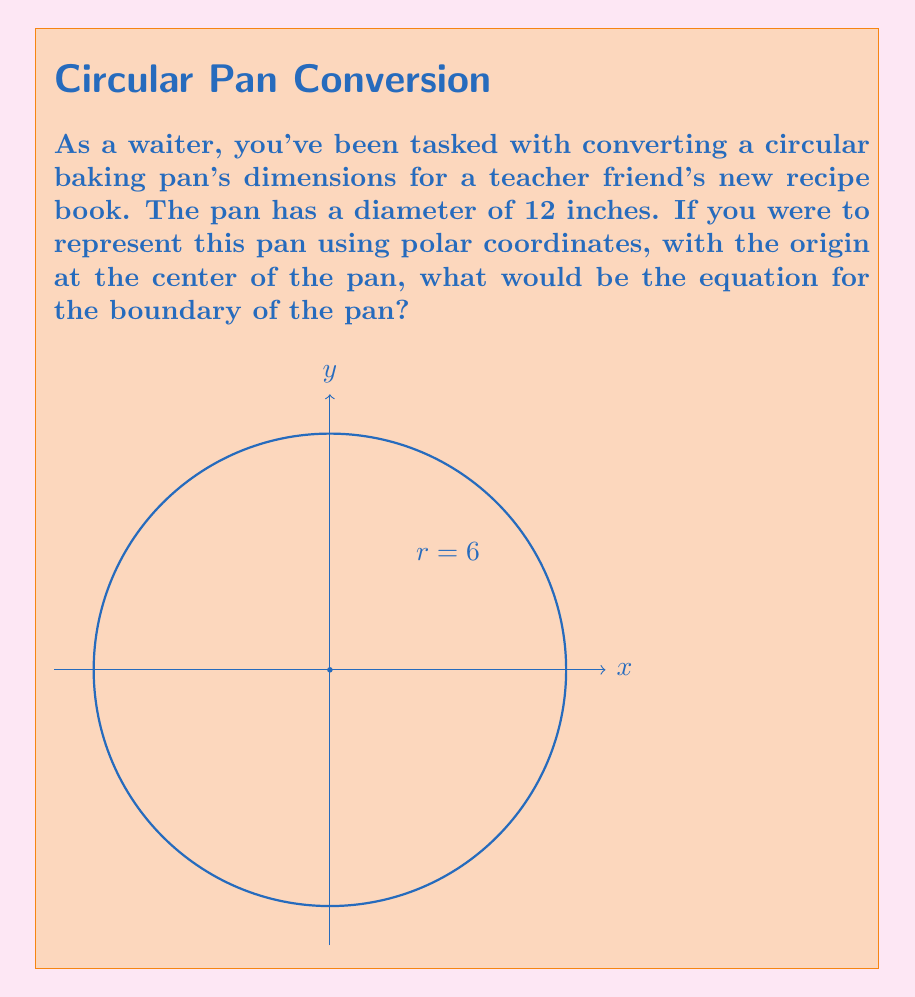Can you solve this math problem? To convert the circular baking pan's dimensions to polar form, we need to follow these steps:

1) First, recall that in polar coordinates, a circle centered at the origin is represented by the equation $r = a$, where $a$ is the radius of the circle.

2) We're given that the diameter of the pan is 12 inches. The radius is half of the diameter:

   $radius = \frac{diameter}{2} = \frac{12}{2} = 6$ inches

3) Therefore, in polar coordinates, any point $(r,\theta)$ on the boundary of the pan will satisfy the equation:

   $r = 6$

4) This equation holds true for all values of $\theta$ from 0 to $2\pi$, which represents a complete rotation around the circle.

5) The full polar equation can be written as:

   $r = 6, \quad 0 \leq \theta < 2\pi$

This equation describes a circle with radius 6 inches, centered at the origin, which matches our baking pan's dimensions.
Answer: $r = 6, \quad 0 \leq \theta < 2\pi$ 